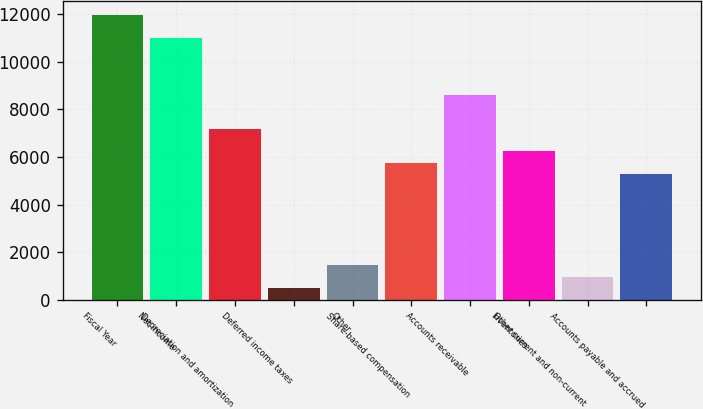Convert chart to OTSL. <chart><loc_0><loc_0><loc_500><loc_500><bar_chart><fcel>Fiscal Year<fcel>Net income<fcel>Depreciation and amortization<fcel>Deferred income taxes<fcel>Other<fcel>Share-based compensation<fcel>Accounts receivable<fcel>Inventories<fcel>Other current and non-current<fcel>Accounts payable and accrued<nl><fcel>11968.5<fcel>11012.3<fcel>7187.5<fcel>494.1<fcel>1450.3<fcel>5753.2<fcel>8621.8<fcel>6231.3<fcel>972.2<fcel>5275.1<nl></chart> 